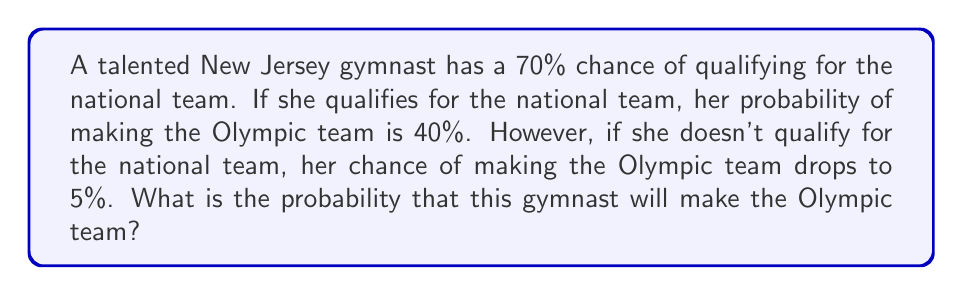Can you answer this question? Let's approach this problem using Bayes' theorem and the law of total probability:

1) Define events:
   N: Qualifying for the national team
   O: Making the Olympic team

2) Given probabilities:
   P(N) = 0.70
   P(O|N) = 0.40
   P(O|not N) = 0.05

3) We want to find P(O). Using the law of total probability:

   $$P(O) = P(O|N) \cdot P(N) + P(O|\text{not }N) \cdot P(\text{not }N)$$

4) We know P(N) = 0.70, so P(not N) = 1 - 0.70 = 0.30

5) Substitute the values:

   $$P(O) = 0.40 \cdot 0.70 + 0.05 \cdot 0.30$$

6) Calculate:

   $$P(O) = 0.28 + 0.015 = 0.295$$

Therefore, the probability of the gymnast making the Olympic team is 0.295 or 29.5%.
Answer: 0.295 or 29.5% 